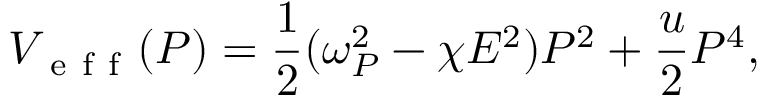<formula> <loc_0><loc_0><loc_500><loc_500>V _ { e f f } ( P ) = \frac { 1 } { 2 } ( \omega _ { P } ^ { 2 } - \chi E ^ { 2 } ) P ^ { 2 } + \frac { u } { 2 } P ^ { 4 } ,</formula> 